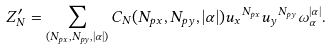<formula> <loc_0><loc_0><loc_500><loc_500>Z _ { N } ^ { \prime } = \sum _ { ( N _ { p x } , N _ { p y } , | \alpha | ) } C _ { N } ( N _ { p x } , N _ { p y } , | \alpha | ) { u _ { x } } ^ { N _ { p x } } { u _ { y } } ^ { N _ { p y } } \omega _ { \alpha } ^ { | \alpha | } .</formula> 